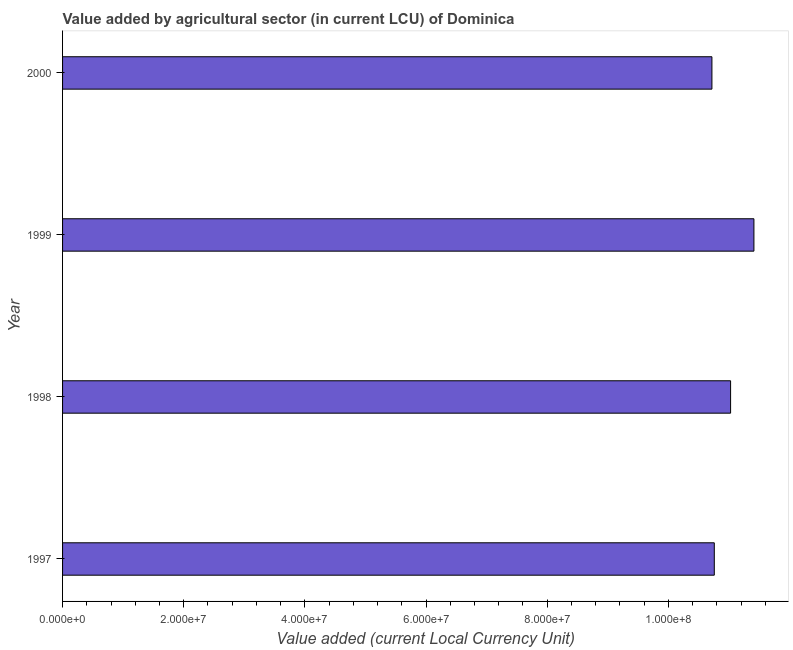Does the graph contain grids?
Make the answer very short. No. What is the title of the graph?
Keep it short and to the point. Value added by agricultural sector (in current LCU) of Dominica. What is the label or title of the X-axis?
Provide a short and direct response. Value added (current Local Currency Unit). What is the label or title of the Y-axis?
Keep it short and to the point. Year. What is the value added by agriculture sector in 1997?
Make the answer very short. 1.08e+08. Across all years, what is the maximum value added by agriculture sector?
Your response must be concise. 1.14e+08. Across all years, what is the minimum value added by agriculture sector?
Provide a succinct answer. 1.07e+08. In which year was the value added by agriculture sector maximum?
Ensure brevity in your answer.  1999. In which year was the value added by agriculture sector minimum?
Ensure brevity in your answer.  2000. What is the sum of the value added by agriculture sector?
Give a very brief answer. 4.39e+08. What is the difference between the value added by agriculture sector in 1997 and 1999?
Keep it short and to the point. -6.54e+06. What is the average value added by agriculture sector per year?
Offer a very short reply. 1.10e+08. What is the median value added by agriculture sector?
Give a very brief answer. 1.09e+08. In how many years, is the value added by agriculture sector greater than 92000000 LCU?
Provide a short and direct response. 4. What is the ratio of the value added by agriculture sector in 1997 to that in 1999?
Your answer should be very brief. 0.94. What is the difference between the highest and the second highest value added by agriculture sector?
Provide a succinct answer. 3.85e+06. What is the difference between the highest and the lowest value added by agriculture sector?
Give a very brief answer. 6.93e+06. In how many years, is the value added by agriculture sector greater than the average value added by agriculture sector taken over all years?
Your answer should be compact. 2. How many bars are there?
Your response must be concise. 4. Are the values on the major ticks of X-axis written in scientific E-notation?
Your answer should be compact. Yes. What is the Value added (current Local Currency Unit) in 1997?
Give a very brief answer. 1.08e+08. What is the Value added (current Local Currency Unit) in 1998?
Offer a terse response. 1.10e+08. What is the Value added (current Local Currency Unit) of 1999?
Offer a terse response. 1.14e+08. What is the Value added (current Local Currency Unit) of 2000?
Make the answer very short. 1.07e+08. What is the difference between the Value added (current Local Currency Unit) in 1997 and 1998?
Give a very brief answer. -2.69e+06. What is the difference between the Value added (current Local Currency Unit) in 1997 and 1999?
Provide a succinct answer. -6.54e+06. What is the difference between the Value added (current Local Currency Unit) in 1997 and 2000?
Your response must be concise. 3.94e+05. What is the difference between the Value added (current Local Currency Unit) in 1998 and 1999?
Make the answer very short. -3.85e+06. What is the difference between the Value added (current Local Currency Unit) in 1998 and 2000?
Provide a short and direct response. 3.08e+06. What is the difference between the Value added (current Local Currency Unit) in 1999 and 2000?
Make the answer very short. 6.93e+06. What is the ratio of the Value added (current Local Currency Unit) in 1997 to that in 1999?
Give a very brief answer. 0.94. What is the ratio of the Value added (current Local Currency Unit) in 1997 to that in 2000?
Ensure brevity in your answer.  1. What is the ratio of the Value added (current Local Currency Unit) in 1998 to that in 1999?
Offer a terse response. 0.97. What is the ratio of the Value added (current Local Currency Unit) in 1999 to that in 2000?
Provide a succinct answer. 1.06. 